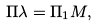Convert formula to latex. <formula><loc_0><loc_0><loc_500><loc_500>\Pi \lambda = \Pi _ { 1 } M ,</formula> 